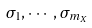Convert formula to latex. <formula><loc_0><loc_0><loc_500><loc_500>\sigma _ { 1 } , \cdots , \sigma _ { m _ { X } }</formula> 